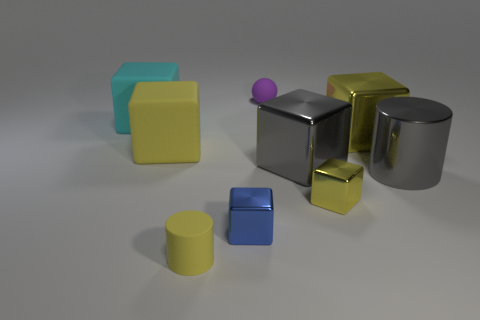Subtract all cyan cylinders. Subtract all brown balls. How many cylinders are left? 2 Subtract all purple cylinders. How many brown cubes are left? 0 Add 9 big yellows. How many small objects exist? 0 Subtract all big yellow objects. Subtract all small yellow cubes. How many objects are left? 6 Add 9 large cyan matte objects. How many large cyan matte objects are left? 10 Add 2 big cyan rubber cubes. How many big cyan rubber cubes exist? 3 Add 1 brown shiny cylinders. How many objects exist? 10 Subtract all gray cubes. How many cubes are left? 5 Subtract all big cyan cubes. How many cubes are left? 5 Subtract 0 gray balls. How many objects are left? 9 